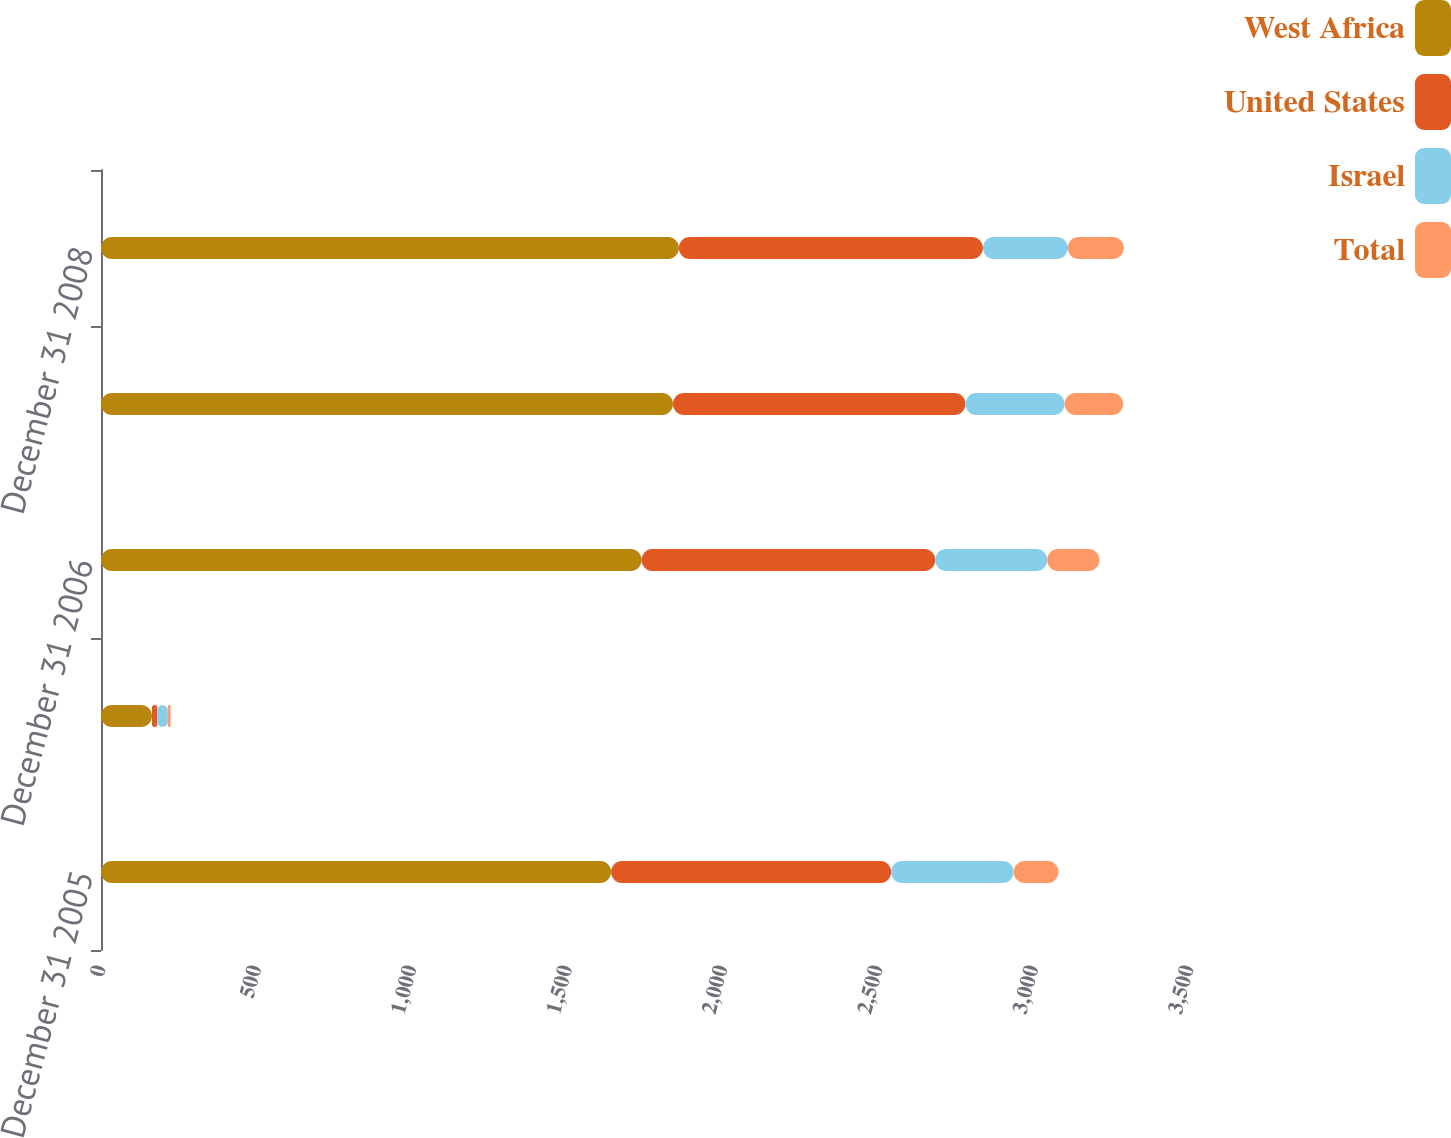<chart> <loc_0><loc_0><loc_500><loc_500><stacked_bar_chart><ecel><fcel>December 31 2005<fcel>Production<fcel>December 31 2006<fcel>December 31 2007<fcel>December 31 2008<nl><fcel>West Africa<fcel>1641<fcel>164<fcel>1739<fcel>1840<fcel>1859<nl><fcel>United States<fcel>901<fcel>17<fcel>945<fcel>941<fcel>978<nl><fcel>Israel<fcel>394<fcel>34<fcel>360<fcel>319<fcel>273<nl><fcel>Total<fcel>144<fcel>9<fcel>168<fcel>188<fcel>180<nl></chart> 